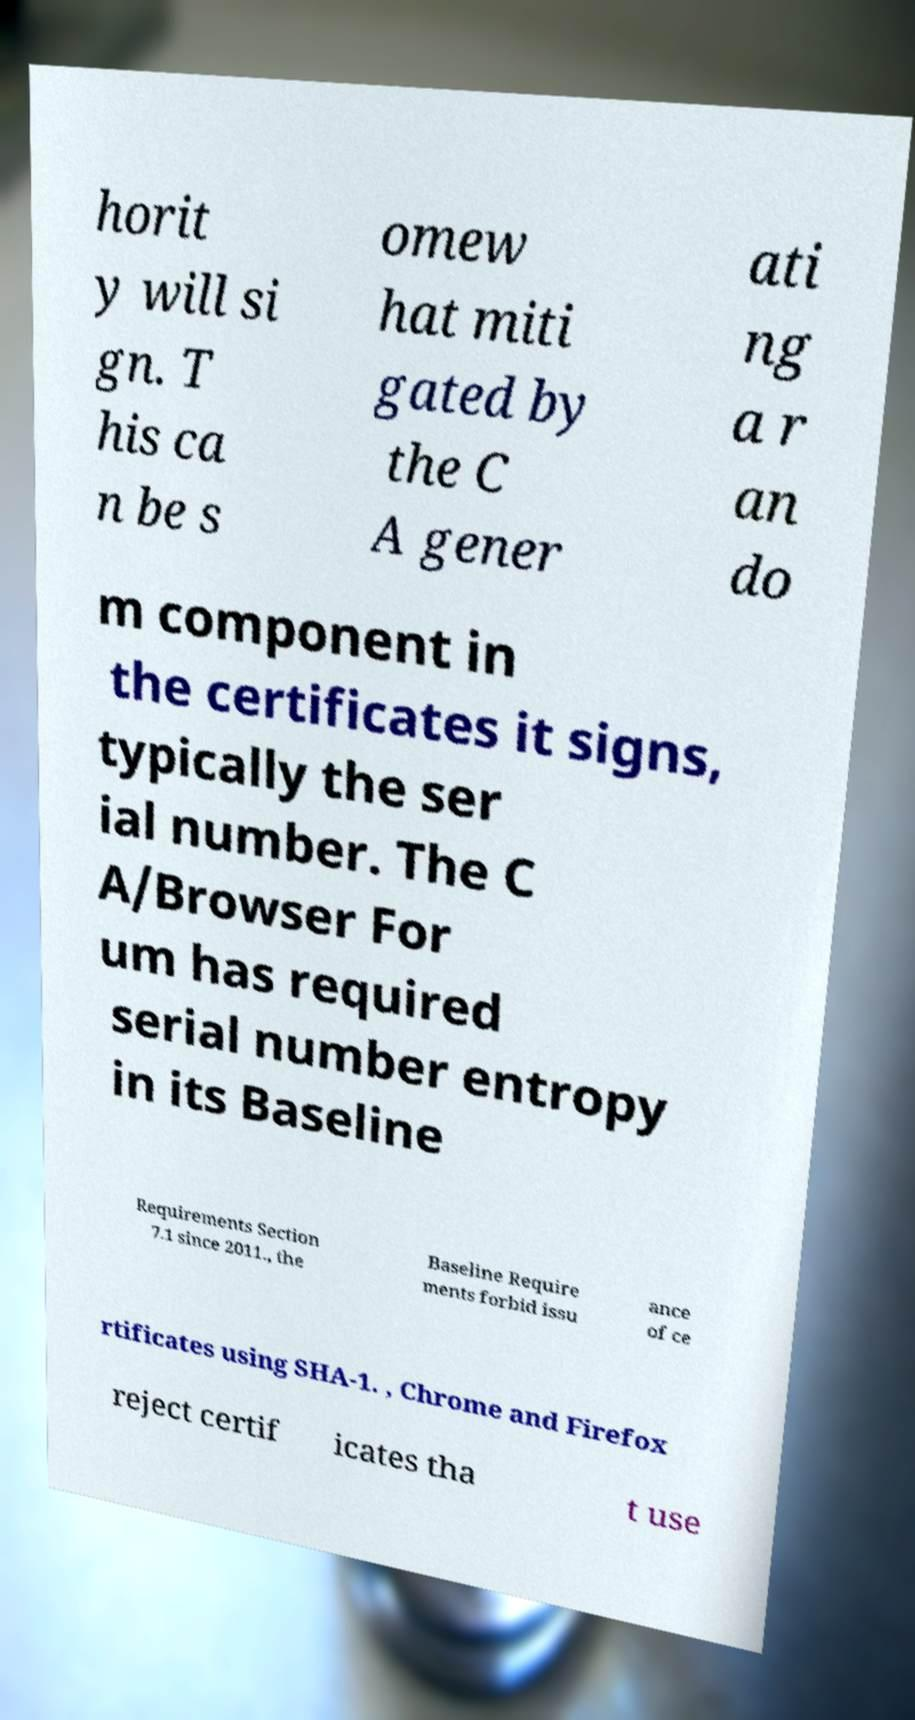Can you accurately transcribe the text from the provided image for me? horit y will si gn. T his ca n be s omew hat miti gated by the C A gener ati ng a r an do m component in the certificates it signs, typically the ser ial number. The C A/Browser For um has required serial number entropy in its Baseline Requirements Section 7.1 since 2011., the Baseline Require ments forbid issu ance of ce rtificates using SHA-1. , Chrome and Firefox reject certif icates tha t use 